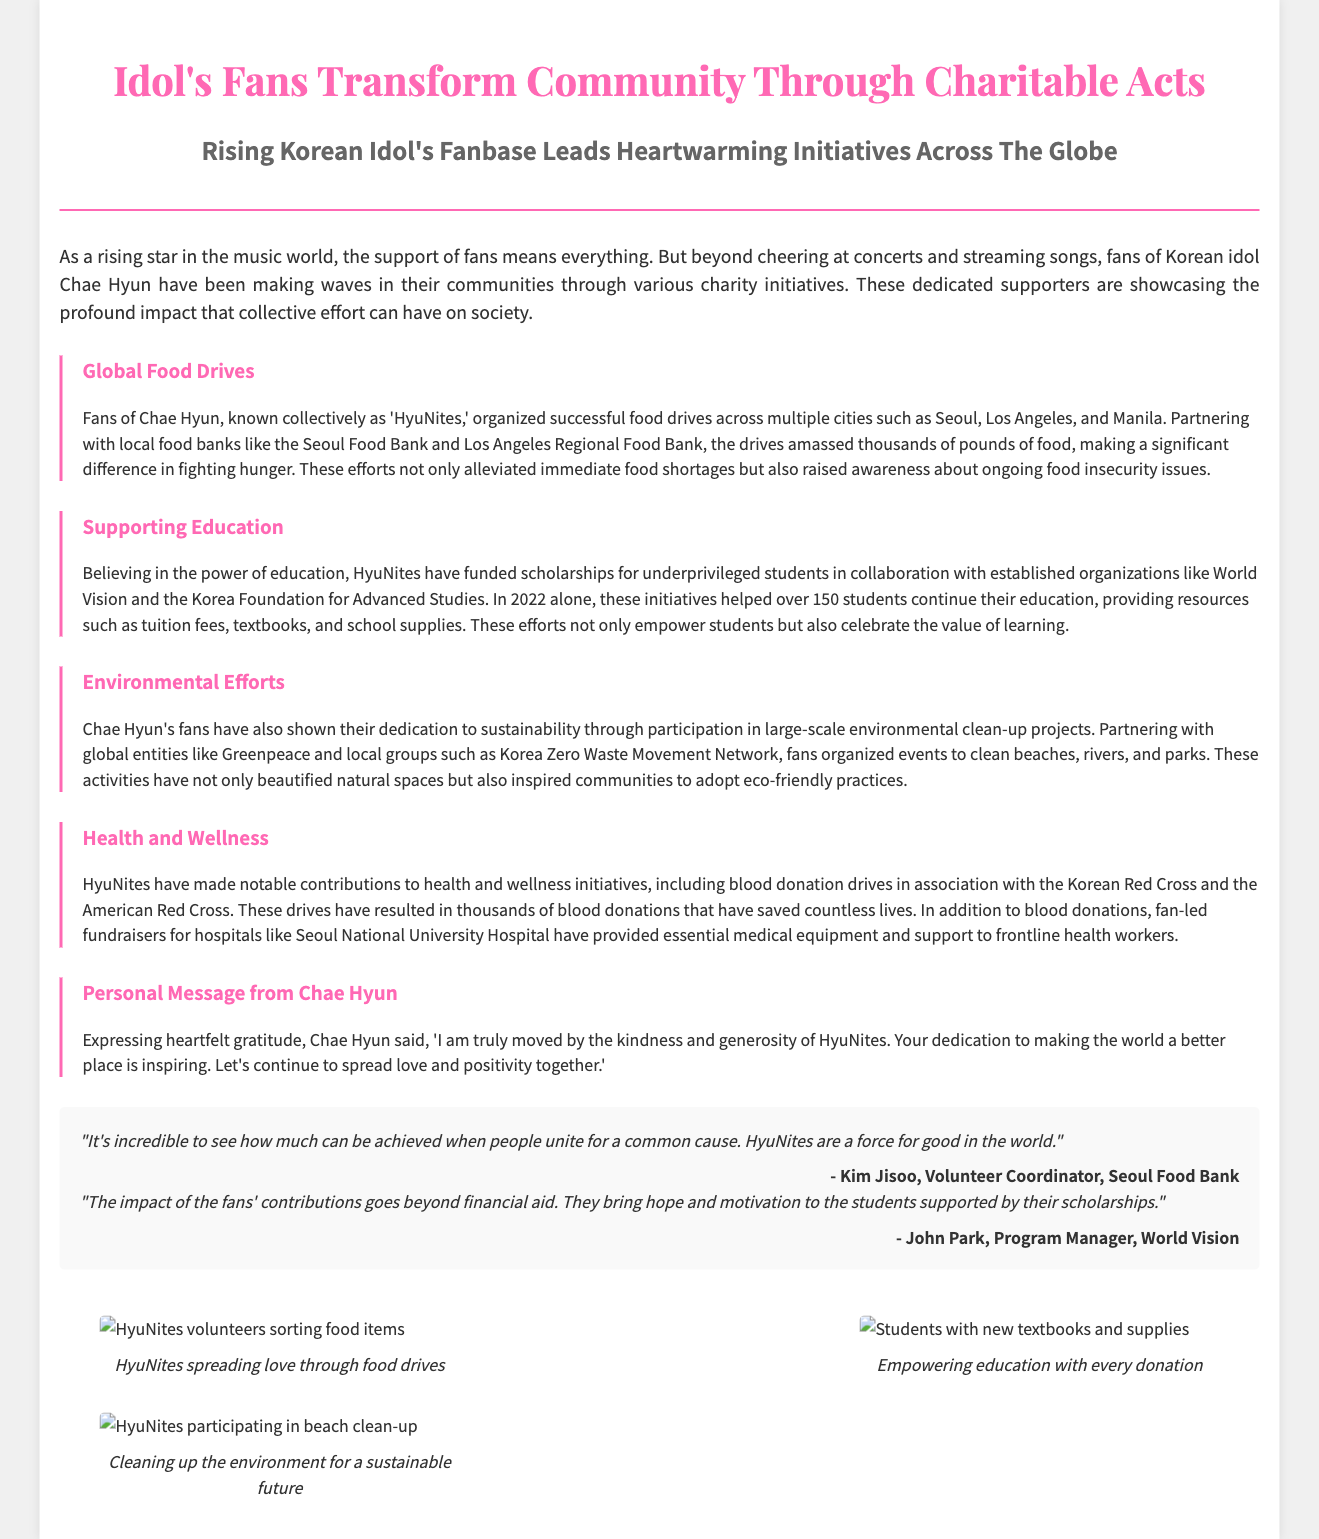What are the fans of Chae Hyun called? The document refers to the fans as "HyuNites."
Answer: HyuNites Which organizations were involved in funding scholarships? The document mentions collaborations with "World Vision" and "the Korea Foundation for Advanced Studies."
Answer: World Vision, the Korea Foundation for Advanced Studies How many students received scholarships in 2022? The document states that over "150 students" benefited from the scholarship initiatives in 2022.
Answer: 150 students What is the primary focus of the health and wellness initiatives? The document highlights contributions to "blood donation drives" and support for "frontline health workers."
Answer: Blood donation drives What did Chae Hyun express gratitude for? Chae Hyun expressed gratitude for the "kindness and generosity of HyuNites."
Answer: Kindness and generosity What type of community work is highlighted in the section about environmental efforts? The document discusses "large-scale environmental clean-up projects" organized by HyuNites.
Answer: Large-scale environmental clean-up projects Which food banks were mentioned in the food drives? The text mentions "Seoul Food Bank" and "Los Angeles Regional Food Bank."
Answer: Seoul Food Bank, Los Angeles Regional Food Bank What quote emphasizes the collective power in charity work? The document includes a quote stating, "It's incredible to see how much can be achieved when people unite for a common cause."
Answer: "It's incredible to see how much can be achieved when people unite for a common cause." 